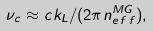<formula> <loc_0><loc_0><loc_500><loc_500>\nu _ { c } \approx c k _ { L } / ( 2 \pi n _ { e \, f \, f } ^ { M G } ) ,</formula> 